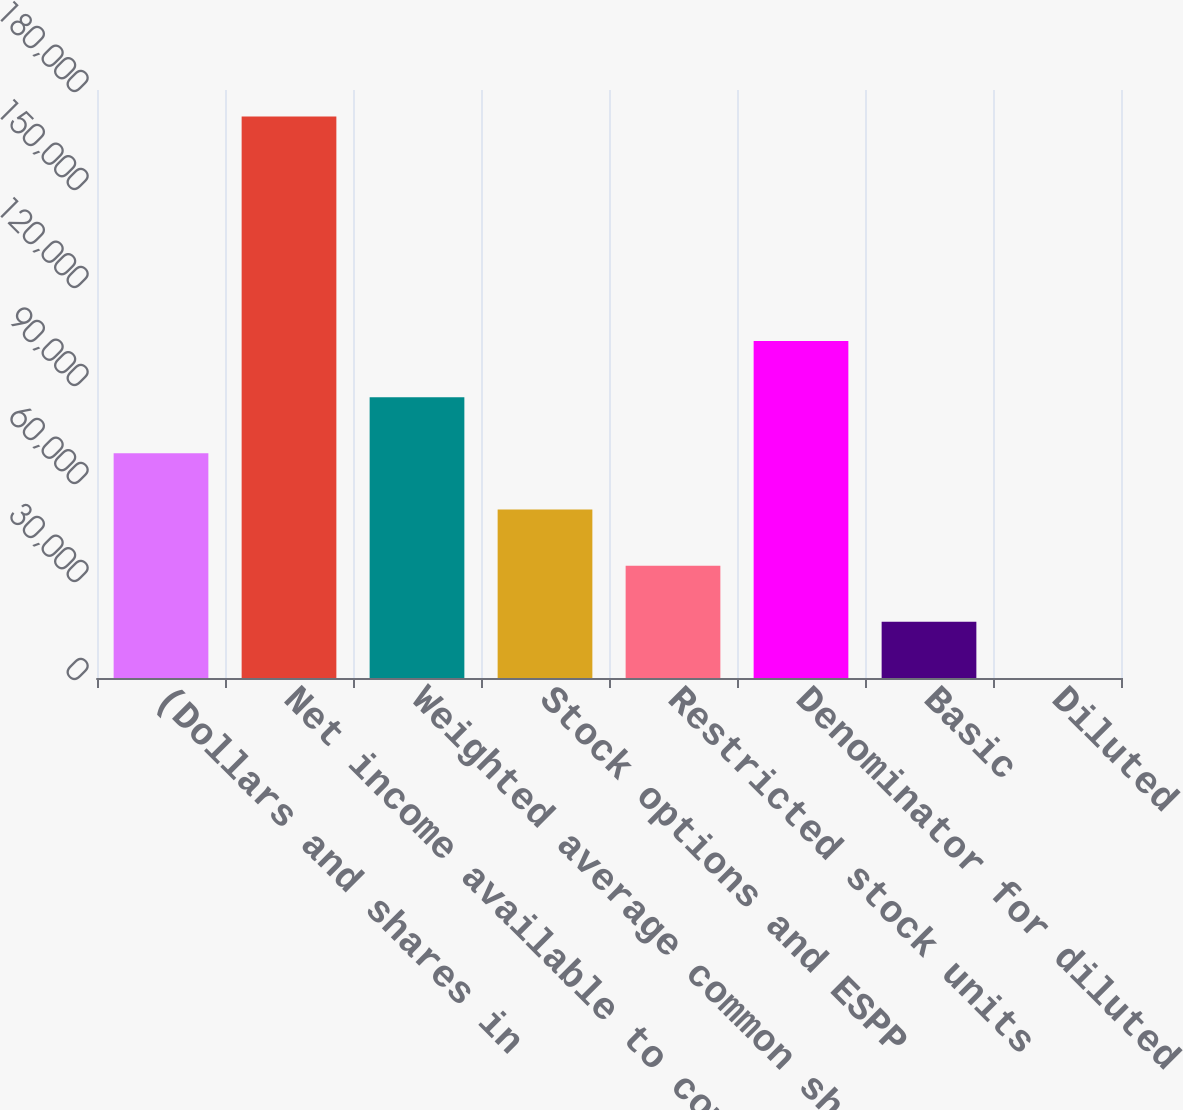Convert chart. <chart><loc_0><loc_0><loc_500><loc_500><bar_chart><fcel>(Dollars and shares in<fcel>Net income available to common<fcel>Weighted average common shares<fcel>Stock options and ESPP<fcel>Restricted stock units<fcel>Denominator for diluted<fcel>Basic<fcel>Diluted<nl><fcel>68763.2<fcel>171902<fcel>85953<fcel>51573.4<fcel>34383.6<fcel>103143<fcel>17193.8<fcel>3.94<nl></chart> 